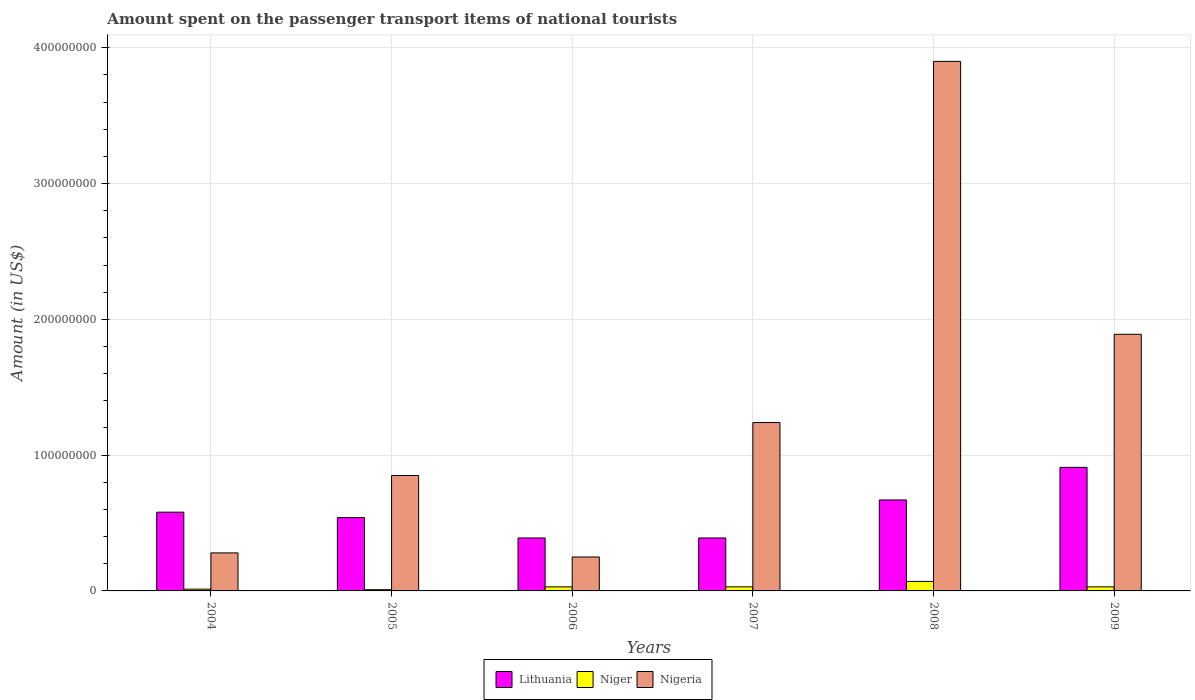Are the number of bars per tick equal to the number of legend labels?
Ensure brevity in your answer.  Yes. Are the number of bars on each tick of the X-axis equal?
Make the answer very short. Yes. In how many cases, is the number of bars for a given year not equal to the number of legend labels?
Offer a terse response. 0. What is the amount spent on the passenger transport items of national tourists in Lithuania in 2008?
Provide a succinct answer. 6.70e+07. Across all years, what is the maximum amount spent on the passenger transport items of national tourists in Lithuania?
Offer a very short reply. 9.10e+07. Across all years, what is the minimum amount spent on the passenger transport items of national tourists in Nigeria?
Ensure brevity in your answer.  2.50e+07. In which year was the amount spent on the passenger transport items of national tourists in Nigeria maximum?
Your answer should be very brief. 2008. In which year was the amount spent on the passenger transport items of national tourists in Niger minimum?
Offer a very short reply. 2005. What is the total amount spent on the passenger transport items of national tourists in Nigeria in the graph?
Your response must be concise. 8.41e+08. What is the difference between the amount spent on the passenger transport items of national tourists in Lithuania in 2004 and that in 2005?
Ensure brevity in your answer.  4.00e+06. What is the difference between the amount spent on the passenger transport items of national tourists in Nigeria in 2005 and the amount spent on the passenger transport items of national tourists in Lithuania in 2006?
Keep it short and to the point. 4.60e+07. What is the average amount spent on the passenger transport items of national tourists in Lithuania per year?
Your answer should be very brief. 5.80e+07. In the year 2006, what is the difference between the amount spent on the passenger transport items of national tourists in Niger and amount spent on the passenger transport items of national tourists in Nigeria?
Your response must be concise. -2.20e+07. In how many years, is the amount spent on the passenger transport items of national tourists in Niger greater than 180000000 US$?
Provide a succinct answer. 0. What is the ratio of the amount spent on the passenger transport items of national tourists in Nigeria in 2007 to that in 2009?
Your answer should be compact. 0.66. What is the difference between the highest and the second highest amount spent on the passenger transport items of national tourists in Lithuania?
Offer a terse response. 2.40e+07. What is the difference between the highest and the lowest amount spent on the passenger transport items of national tourists in Lithuania?
Make the answer very short. 5.20e+07. Is the sum of the amount spent on the passenger transport items of national tourists in Lithuania in 2004 and 2007 greater than the maximum amount spent on the passenger transport items of national tourists in Nigeria across all years?
Offer a terse response. No. What does the 1st bar from the left in 2009 represents?
Offer a terse response. Lithuania. What does the 2nd bar from the right in 2004 represents?
Give a very brief answer. Niger. Are all the bars in the graph horizontal?
Offer a very short reply. No. How many years are there in the graph?
Your answer should be compact. 6. Does the graph contain grids?
Your response must be concise. Yes. What is the title of the graph?
Offer a terse response. Amount spent on the passenger transport items of national tourists. Does "Isle of Man" appear as one of the legend labels in the graph?
Your answer should be very brief. No. What is the Amount (in US$) of Lithuania in 2004?
Your answer should be compact. 5.80e+07. What is the Amount (in US$) of Niger in 2004?
Provide a short and direct response. 1.30e+06. What is the Amount (in US$) in Nigeria in 2004?
Make the answer very short. 2.80e+07. What is the Amount (in US$) in Lithuania in 2005?
Provide a short and direct response. 5.40e+07. What is the Amount (in US$) of Nigeria in 2005?
Your response must be concise. 8.50e+07. What is the Amount (in US$) in Lithuania in 2006?
Give a very brief answer. 3.90e+07. What is the Amount (in US$) of Nigeria in 2006?
Your answer should be very brief. 2.50e+07. What is the Amount (in US$) of Lithuania in 2007?
Give a very brief answer. 3.90e+07. What is the Amount (in US$) in Nigeria in 2007?
Keep it short and to the point. 1.24e+08. What is the Amount (in US$) in Lithuania in 2008?
Make the answer very short. 6.70e+07. What is the Amount (in US$) of Niger in 2008?
Ensure brevity in your answer.  7.00e+06. What is the Amount (in US$) in Nigeria in 2008?
Provide a short and direct response. 3.90e+08. What is the Amount (in US$) in Lithuania in 2009?
Provide a succinct answer. 9.10e+07. What is the Amount (in US$) in Nigeria in 2009?
Give a very brief answer. 1.89e+08. Across all years, what is the maximum Amount (in US$) in Lithuania?
Keep it short and to the point. 9.10e+07. Across all years, what is the maximum Amount (in US$) of Niger?
Ensure brevity in your answer.  7.00e+06. Across all years, what is the maximum Amount (in US$) in Nigeria?
Offer a very short reply. 3.90e+08. Across all years, what is the minimum Amount (in US$) of Lithuania?
Keep it short and to the point. 3.90e+07. Across all years, what is the minimum Amount (in US$) in Nigeria?
Provide a short and direct response. 2.50e+07. What is the total Amount (in US$) in Lithuania in the graph?
Your answer should be compact. 3.48e+08. What is the total Amount (in US$) of Niger in the graph?
Keep it short and to the point. 1.82e+07. What is the total Amount (in US$) in Nigeria in the graph?
Ensure brevity in your answer.  8.41e+08. What is the difference between the Amount (in US$) of Niger in 2004 and that in 2005?
Your answer should be very brief. 4.00e+05. What is the difference between the Amount (in US$) of Nigeria in 2004 and that in 2005?
Give a very brief answer. -5.70e+07. What is the difference between the Amount (in US$) of Lithuania in 2004 and that in 2006?
Offer a very short reply. 1.90e+07. What is the difference between the Amount (in US$) in Niger in 2004 and that in 2006?
Give a very brief answer. -1.70e+06. What is the difference between the Amount (in US$) of Nigeria in 2004 and that in 2006?
Your response must be concise. 3.00e+06. What is the difference between the Amount (in US$) of Lithuania in 2004 and that in 2007?
Provide a short and direct response. 1.90e+07. What is the difference between the Amount (in US$) in Niger in 2004 and that in 2007?
Offer a terse response. -1.70e+06. What is the difference between the Amount (in US$) of Nigeria in 2004 and that in 2007?
Keep it short and to the point. -9.60e+07. What is the difference between the Amount (in US$) in Lithuania in 2004 and that in 2008?
Your response must be concise. -9.00e+06. What is the difference between the Amount (in US$) in Niger in 2004 and that in 2008?
Your answer should be very brief. -5.70e+06. What is the difference between the Amount (in US$) of Nigeria in 2004 and that in 2008?
Provide a short and direct response. -3.62e+08. What is the difference between the Amount (in US$) of Lithuania in 2004 and that in 2009?
Make the answer very short. -3.30e+07. What is the difference between the Amount (in US$) in Niger in 2004 and that in 2009?
Provide a short and direct response. -1.70e+06. What is the difference between the Amount (in US$) of Nigeria in 2004 and that in 2009?
Your answer should be very brief. -1.61e+08. What is the difference between the Amount (in US$) in Lithuania in 2005 and that in 2006?
Keep it short and to the point. 1.50e+07. What is the difference between the Amount (in US$) of Niger in 2005 and that in 2006?
Your response must be concise. -2.10e+06. What is the difference between the Amount (in US$) in Nigeria in 2005 and that in 2006?
Offer a very short reply. 6.00e+07. What is the difference between the Amount (in US$) in Lithuania in 2005 and that in 2007?
Ensure brevity in your answer.  1.50e+07. What is the difference between the Amount (in US$) of Niger in 2005 and that in 2007?
Your answer should be compact. -2.10e+06. What is the difference between the Amount (in US$) of Nigeria in 2005 and that in 2007?
Offer a very short reply. -3.90e+07. What is the difference between the Amount (in US$) of Lithuania in 2005 and that in 2008?
Provide a short and direct response. -1.30e+07. What is the difference between the Amount (in US$) of Niger in 2005 and that in 2008?
Provide a short and direct response. -6.10e+06. What is the difference between the Amount (in US$) in Nigeria in 2005 and that in 2008?
Give a very brief answer. -3.05e+08. What is the difference between the Amount (in US$) in Lithuania in 2005 and that in 2009?
Give a very brief answer. -3.70e+07. What is the difference between the Amount (in US$) in Niger in 2005 and that in 2009?
Your answer should be very brief. -2.10e+06. What is the difference between the Amount (in US$) in Nigeria in 2005 and that in 2009?
Offer a terse response. -1.04e+08. What is the difference between the Amount (in US$) in Nigeria in 2006 and that in 2007?
Offer a terse response. -9.90e+07. What is the difference between the Amount (in US$) in Lithuania in 2006 and that in 2008?
Your response must be concise. -2.80e+07. What is the difference between the Amount (in US$) of Nigeria in 2006 and that in 2008?
Provide a short and direct response. -3.65e+08. What is the difference between the Amount (in US$) of Lithuania in 2006 and that in 2009?
Provide a succinct answer. -5.20e+07. What is the difference between the Amount (in US$) of Niger in 2006 and that in 2009?
Make the answer very short. 0. What is the difference between the Amount (in US$) in Nigeria in 2006 and that in 2009?
Your answer should be compact. -1.64e+08. What is the difference between the Amount (in US$) in Lithuania in 2007 and that in 2008?
Your answer should be very brief. -2.80e+07. What is the difference between the Amount (in US$) in Niger in 2007 and that in 2008?
Provide a short and direct response. -4.00e+06. What is the difference between the Amount (in US$) of Nigeria in 2007 and that in 2008?
Provide a succinct answer. -2.66e+08. What is the difference between the Amount (in US$) of Lithuania in 2007 and that in 2009?
Offer a very short reply. -5.20e+07. What is the difference between the Amount (in US$) in Nigeria in 2007 and that in 2009?
Provide a succinct answer. -6.50e+07. What is the difference between the Amount (in US$) of Lithuania in 2008 and that in 2009?
Offer a very short reply. -2.40e+07. What is the difference between the Amount (in US$) of Niger in 2008 and that in 2009?
Offer a terse response. 4.00e+06. What is the difference between the Amount (in US$) in Nigeria in 2008 and that in 2009?
Keep it short and to the point. 2.01e+08. What is the difference between the Amount (in US$) in Lithuania in 2004 and the Amount (in US$) in Niger in 2005?
Offer a terse response. 5.71e+07. What is the difference between the Amount (in US$) of Lithuania in 2004 and the Amount (in US$) of Nigeria in 2005?
Offer a terse response. -2.70e+07. What is the difference between the Amount (in US$) in Niger in 2004 and the Amount (in US$) in Nigeria in 2005?
Ensure brevity in your answer.  -8.37e+07. What is the difference between the Amount (in US$) of Lithuania in 2004 and the Amount (in US$) of Niger in 2006?
Give a very brief answer. 5.50e+07. What is the difference between the Amount (in US$) of Lithuania in 2004 and the Amount (in US$) of Nigeria in 2006?
Your response must be concise. 3.30e+07. What is the difference between the Amount (in US$) in Niger in 2004 and the Amount (in US$) in Nigeria in 2006?
Ensure brevity in your answer.  -2.37e+07. What is the difference between the Amount (in US$) in Lithuania in 2004 and the Amount (in US$) in Niger in 2007?
Provide a short and direct response. 5.50e+07. What is the difference between the Amount (in US$) of Lithuania in 2004 and the Amount (in US$) of Nigeria in 2007?
Your response must be concise. -6.60e+07. What is the difference between the Amount (in US$) of Niger in 2004 and the Amount (in US$) of Nigeria in 2007?
Offer a terse response. -1.23e+08. What is the difference between the Amount (in US$) in Lithuania in 2004 and the Amount (in US$) in Niger in 2008?
Provide a short and direct response. 5.10e+07. What is the difference between the Amount (in US$) of Lithuania in 2004 and the Amount (in US$) of Nigeria in 2008?
Your answer should be compact. -3.32e+08. What is the difference between the Amount (in US$) of Niger in 2004 and the Amount (in US$) of Nigeria in 2008?
Provide a succinct answer. -3.89e+08. What is the difference between the Amount (in US$) of Lithuania in 2004 and the Amount (in US$) of Niger in 2009?
Provide a short and direct response. 5.50e+07. What is the difference between the Amount (in US$) in Lithuania in 2004 and the Amount (in US$) in Nigeria in 2009?
Make the answer very short. -1.31e+08. What is the difference between the Amount (in US$) in Niger in 2004 and the Amount (in US$) in Nigeria in 2009?
Your answer should be very brief. -1.88e+08. What is the difference between the Amount (in US$) in Lithuania in 2005 and the Amount (in US$) in Niger in 2006?
Your answer should be very brief. 5.10e+07. What is the difference between the Amount (in US$) in Lithuania in 2005 and the Amount (in US$) in Nigeria in 2006?
Your answer should be compact. 2.90e+07. What is the difference between the Amount (in US$) of Niger in 2005 and the Amount (in US$) of Nigeria in 2006?
Your answer should be very brief. -2.41e+07. What is the difference between the Amount (in US$) in Lithuania in 2005 and the Amount (in US$) in Niger in 2007?
Your answer should be compact. 5.10e+07. What is the difference between the Amount (in US$) in Lithuania in 2005 and the Amount (in US$) in Nigeria in 2007?
Provide a short and direct response. -7.00e+07. What is the difference between the Amount (in US$) in Niger in 2005 and the Amount (in US$) in Nigeria in 2007?
Give a very brief answer. -1.23e+08. What is the difference between the Amount (in US$) in Lithuania in 2005 and the Amount (in US$) in Niger in 2008?
Keep it short and to the point. 4.70e+07. What is the difference between the Amount (in US$) of Lithuania in 2005 and the Amount (in US$) of Nigeria in 2008?
Offer a terse response. -3.36e+08. What is the difference between the Amount (in US$) of Niger in 2005 and the Amount (in US$) of Nigeria in 2008?
Offer a very short reply. -3.89e+08. What is the difference between the Amount (in US$) in Lithuania in 2005 and the Amount (in US$) in Niger in 2009?
Your answer should be very brief. 5.10e+07. What is the difference between the Amount (in US$) of Lithuania in 2005 and the Amount (in US$) of Nigeria in 2009?
Give a very brief answer. -1.35e+08. What is the difference between the Amount (in US$) in Niger in 2005 and the Amount (in US$) in Nigeria in 2009?
Provide a succinct answer. -1.88e+08. What is the difference between the Amount (in US$) in Lithuania in 2006 and the Amount (in US$) in Niger in 2007?
Offer a very short reply. 3.60e+07. What is the difference between the Amount (in US$) of Lithuania in 2006 and the Amount (in US$) of Nigeria in 2007?
Offer a terse response. -8.50e+07. What is the difference between the Amount (in US$) of Niger in 2006 and the Amount (in US$) of Nigeria in 2007?
Your answer should be very brief. -1.21e+08. What is the difference between the Amount (in US$) of Lithuania in 2006 and the Amount (in US$) of Niger in 2008?
Your answer should be compact. 3.20e+07. What is the difference between the Amount (in US$) of Lithuania in 2006 and the Amount (in US$) of Nigeria in 2008?
Give a very brief answer. -3.51e+08. What is the difference between the Amount (in US$) in Niger in 2006 and the Amount (in US$) in Nigeria in 2008?
Ensure brevity in your answer.  -3.87e+08. What is the difference between the Amount (in US$) in Lithuania in 2006 and the Amount (in US$) in Niger in 2009?
Offer a terse response. 3.60e+07. What is the difference between the Amount (in US$) in Lithuania in 2006 and the Amount (in US$) in Nigeria in 2009?
Your answer should be compact. -1.50e+08. What is the difference between the Amount (in US$) of Niger in 2006 and the Amount (in US$) of Nigeria in 2009?
Provide a succinct answer. -1.86e+08. What is the difference between the Amount (in US$) of Lithuania in 2007 and the Amount (in US$) of Niger in 2008?
Your answer should be compact. 3.20e+07. What is the difference between the Amount (in US$) in Lithuania in 2007 and the Amount (in US$) in Nigeria in 2008?
Provide a short and direct response. -3.51e+08. What is the difference between the Amount (in US$) in Niger in 2007 and the Amount (in US$) in Nigeria in 2008?
Provide a succinct answer. -3.87e+08. What is the difference between the Amount (in US$) in Lithuania in 2007 and the Amount (in US$) in Niger in 2009?
Offer a terse response. 3.60e+07. What is the difference between the Amount (in US$) in Lithuania in 2007 and the Amount (in US$) in Nigeria in 2009?
Ensure brevity in your answer.  -1.50e+08. What is the difference between the Amount (in US$) in Niger in 2007 and the Amount (in US$) in Nigeria in 2009?
Offer a very short reply. -1.86e+08. What is the difference between the Amount (in US$) in Lithuania in 2008 and the Amount (in US$) in Niger in 2009?
Offer a terse response. 6.40e+07. What is the difference between the Amount (in US$) in Lithuania in 2008 and the Amount (in US$) in Nigeria in 2009?
Offer a terse response. -1.22e+08. What is the difference between the Amount (in US$) of Niger in 2008 and the Amount (in US$) of Nigeria in 2009?
Keep it short and to the point. -1.82e+08. What is the average Amount (in US$) of Lithuania per year?
Keep it short and to the point. 5.80e+07. What is the average Amount (in US$) in Niger per year?
Keep it short and to the point. 3.03e+06. What is the average Amount (in US$) of Nigeria per year?
Your answer should be compact. 1.40e+08. In the year 2004, what is the difference between the Amount (in US$) in Lithuania and Amount (in US$) in Niger?
Your answer should be compact. 5.67e+07. In the year 2004, what is the difference between the Amount (in US$) of Lithuania and Amount (in US$) of Nigeria?
Offer a terse response. 3.00e+07. In the year 2004, what is the difference between the Amount (in US$) of Niger and Amount (in US$) of Nigeria?
Your answer should be compact. -2.67e+07. In the year 2005, what is the difference between the Amount (in US$) of Lithuania and Amount (in US$) of Niger?
Provide a short and direct response. 5.31e+07. In the year 2005, what is the difference between the Amount (in US$) in Lithuania and Amount (in US$) in Nigeria?
Your response must be concise. -3.10e+07. In the year 2005, what is the difference between the Amount (in US$) in Niger and Amount (in US$) in Nigeria?
Offer a terse response. -8.41e+07. In the year 2006, what is the difference between the Amount (in US$) in Lithuania and Amount (in US$) in Niger?
Make the answer very short. 3.60e+07. In the year 2006, what is the difference between the Amount (in US$) in Lithuania and Amount (in US$) in Nigeria?
Offer a very short reply. 1.40e+07. In the year 2006, what is the difference between the Amount (in US$) in Niger and Amount (in US$) in Nigeria?
Keep it short and to the point. -2.20e+07. In the year 2007, what is the difference between the Amount (in US$) of Lithuania and Amount (in US$) of Niger?
Offer a very short reply. 3.60e+07. In the year 2007, what is the difference between the Amount (in US$) of Lithuania and Amount (in US$) of Nigeria?
Give a very brief answer. -8.50e+07. In the year 2007, what is the difference between the Amount (in US$) in Niger and Amount (in US$) in Nigeria?
Offer a terse response. -1.21e+08. In the year 2008, what is the difference between the Amount (in US$) of Lithuania and Amount (in US$) of Niger?
Keep it short and to the point. 6.00e+07. In the year 2008, what is the difference between the Amount (in US$) of Lithuania and Amount (in US$) of Nigeria?
Give a very brief answer. -3.23e+08. In the year 2008, what is the difference between the Amount (in US$) in Niger and Amount (in US$) in Nigeria?
Keep it short and to the point. -3.83e+08. In the year 2009, what is the difference between the Amount (in US$) of Lithuania and Amount (in US$) of Niger?
Offer a terse response. 8.80e+07. In the year 2009, what is the difference between the Amount (in US$) in Lithuania and Amount (in US$) in Nigeria?
Your answer should be very brief. -9.80e+07. In the year 2009, what is the difference between the Amount (in US$) in Niger and Amount (in US$) in Nigeria?
Your response must be concise. -1.86e+08. What is the ratio of the Amount (in US$) in Lithuania in 2004 to that in 2005?
Offer a terse response. 1.07. What is the ratio of the Amount (in US$) in Niger in 2004 to that in 2005?
Provide a short and direct response. 1.44. What is the ratio of the Amount (in US$) of Nigeria in 2004 to that in 2005?
Offer a terse response. 0.33. What is the ratio of the Amount (in US$) in Lithuania in 2004 to that in 2006?
Give a very brief answer. 1.49. What is the ratio of the Amount (in US$) of Niger in 2004 to that in 2006?
Give a very brief answer. 0.43. What is the ratio of the Amount (in US$) in Nigeria in 2004 to that in 2006?
Provide a short and direct response. 1.12. What is the ratio of the Amount (in US$) in Lithuania in 2004 to that in 2007?
Keep it short and to the point. 1.49. What is the ratio of the Amount (in US$) in Niger in 2004 to that in 2007?
Your answer should be very brief. 0.43. What is the ratio of the Amount (in US$) in Nigeria in 2004 to that in 2007?
Provide a succinct answer. 0.23. What is the ratio of the Amount (in US$) in Lithuania in 2004 to that in 2008?
Offer a terse response. 0.87. What is the ratio of the Amount (in US$) in Niger in 2004 to that in 2008?
Provide a succinct answer. 0.19. What is the ratio of the Amount (in US$) of Nigeria in 2004 to that in 2008?
Provide a succinct answer. 0.07. What is the ratio of the Amount (in US$) of Lithuania in 2004 to that in 2009?
Your answer should be compact. 0.64. What is the ratio of the Amount (in US$) of Niger in 2004 to that in 2009?
Your answer should be compact. 0.43. What is the ratio of the Amount (in US$) in Nigeria in 2004 to that in 2009?
Your response must be concise. 0.15. What is the ratio of the Amount (in US$) of Lithuania in 2005 to that in 2006?
Offer a very short reply. 1.38. What is the ratio of the Amount (in US$) of Nigeria in 2005 to that in 2006?
Your response must be concise. 3.4. What is the ratio of the Amount (in US$) of Lithuania in 2005 to that in 2007?
Your response must be concise. 1.38. What is the ratio of the Amount (in US$) of Nigeria in 2005 to that in 2007?
Your answer should be compact. 0.69. What is the ratio of the Amount (in US$) of Lithuania in 2005 to that in 2008?
Give a very brief answer. 0.81. What is the ratio of the Amount (in US$) of Niger in 2005 to that in 2008?
Your answer should be compact. 0.13. What is the ratio of the Amount (in US$) of Nigeria in 2005 to that in 2008?
Provide a succinct answer. 0.22. What is the ratio of the Amount (in US$) in Lithuania in 2005 to that in 2009?
Provide a succinct answer. 0.59. What is the ratio of the Amount (in US$) in Niger in 2005 to that in 2009?
Provide a short and direct response. 0.3. What is the ratio of the Amount (in US$) of Nigeria in 2005 to that in 2009?
Make the answer very short. 0.45. What is the ratio of the Amount (in US$) in Nigeria in 2006 to that in 2007?
Offer a very short reply. 0.2. What is the ratio of the Amount (in US$) in Lithuania in 2006 to that in 2008?
Your answer should be compact. 0.58. What is the ratio of the Amount (in US$) in Niger in 2006 to that in 2008?
Provide a short and direct response. 0.43. What is the ratio of the Amount (in US$) of Nigeria in 2006 to that in 2008?
Offer a terse response. 0.06. What is the ratio of the Amount (in US$) of Lithuania in 2006 to that in 2009?
Provide a succinct answer. 0.43. What is the ratio of the Amount (in US$) in Niger in 2006 to that in 2009?
Your answer should be very brief. 1. What is the ratio of the Amount (in US$) in Nigeria in 2006 to that in 2009?
Make the answer very short. 0.13. What is the ratio of the Amount (in US$) in Lithuania in 2007 to that in 2008?
Provide a short and direct response. 0.58. What is the ratio of the Amount (in US$) in Niger in 2007 to that in 2008?
Provide a succinct answer. 0.43. What is the ratio of the Amount (in US$) of Nigeria in 2007 to that in 2008?
Ensure brevity in your answer.  0.32. What is the ratio of the Amount (in US$) of Lithuania in 2007 to that in 2009?
Provide a short and direct response. 0.43. What is the ratio of the Amount (in US$) of Nigeria in 2007 to that in 2009?
Offer a very short reply. 0.66. What is the ratio of the Amount (in US$) of Lithuania in 2008 to that in 2009?
Your answer should be compact. 0.74. What is the ratio of the Amount (in US$) of Niger in 2008 to that in 2009?
Your answer should be very brief. 2.33. What is the ratio of the Amount (in US$) of Nigeria in 2008 to that in 2009?
Your answer should be compact. 2.06. What is the difference between the highest and the second highest Amount (in US$) in Lithuania?
Ensure brevity in your answer.  2.40e+07. What is the difference between the highest and the second highest Amount (in US$) of Nigeria?
Your response must be concise. 2.01e+08. What is the difference between the highest and the lowest Amount (in US$) in Lithuania?
Your answer should be compact. 5.20e+07. What is the difference between the highest and the lowest Amount (in US$) of Niger?
Offer a very short reply. 6.10e+06. What is the difference between the highest and the lowest Amount (in US$) in Nigeria?
Provide a succinct answer. 3.65e+08. 